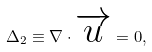Convert formula to latex. <formula><loc_0><loc_0><loc_500><loc_500>\Delta _ { 2 } \equiv \nabla \cdot \overrightarrow { u } = 0 ,</formula> 